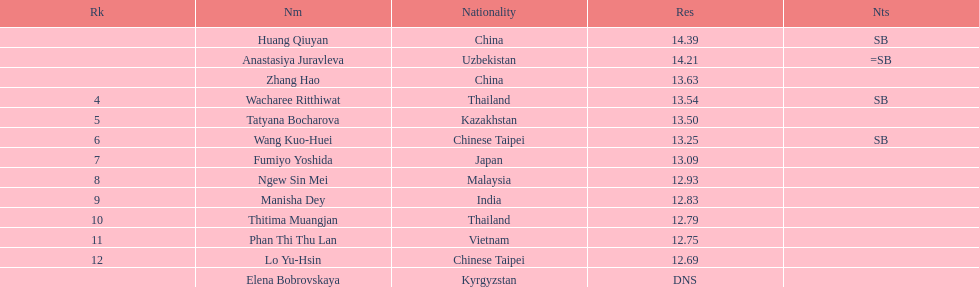What is the number of different nationalities represented by the top 5 athletes? 4. 